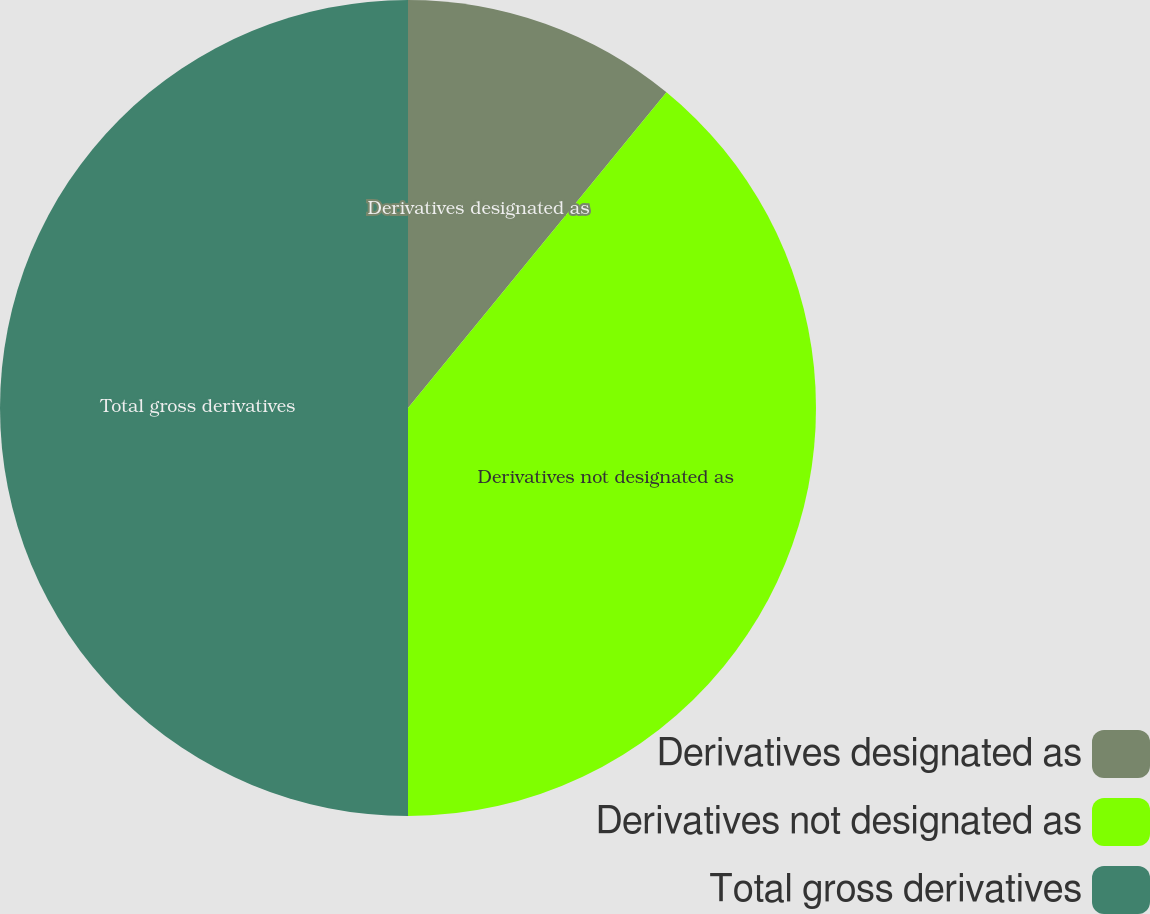Convert chart. <chart><loc_0><loc_0><loc_500><loc_500><pie_chart><fcel>Derivatives designated as<fcel>Derivatives not designated as<fcel>Total gross derivatives<nl><fcel>10.92%<fcel>39.08%<fcel>50.0%<nl></chart> 